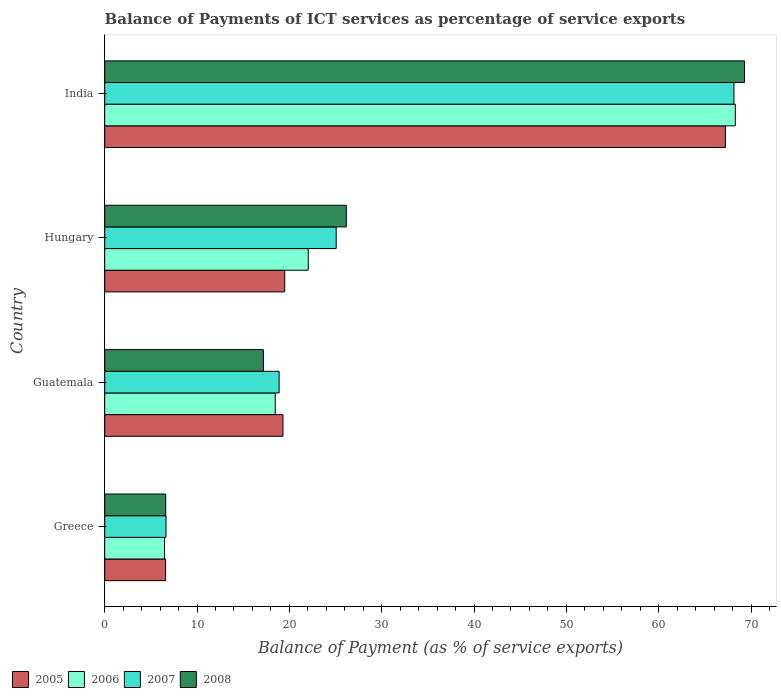Are the number of bars per tick equal to the number of legend labels?
Ensure brevity in your answer.  Yes. How many bars are there on the 4th tick from the bottom?
Give a very brief answer. 4. What is the label of the 2nd group of bars from the top?
Your response must be concise. Hungary. What is the balance of payments of ICT services in 2005 in Hungary?
Give a very brief answer. 19.5. Across all countries, what is the maximum balance of payments of ICT services in 2006?
Provide a short and direct response. 68.29. Across all countries, what is the minimum balance of payments of ICT services in 2008?
Your answer should be compact. 6.6. In which country was the balance of payments of ICT services in 2005 maximum?
Your response must be concise. India. What is the total balance of payments of ICT services in 2006 in the graph?
Ensure brevity in your answer.  115.28. What is the difference between the balance of payments of ICT services in 2008 in Hungary and that in India?
Give a very brief answer. -43.12. What is the difference between the balance of payments of ICT services in 2007 in India and the balance of payments of ICT services in 2008 in Hungary?
Offer a terse response. 41.98. What is the average balance of payments of ICT services in 2006 per country?
Keep it short and to the point. 28.82. What is the difference between the balance of payments of ICT services in 2006 and balance of payments of ICT services in 2008 in Hungary?
Your answer should be compact. -4.13. What is the ratio of the balance of payments of ICT services in 2005 in Greece to that in India?
Give a very brief answer. 0.1. Is the balance of payments of ICT services in 2008 in Hungary less than that in India?
Your answer should be very brief. Yes. Is the difference between the balance of payments of ICT services in 2006 in Greece and India greater than the difference between the balance of payments of ICT services in 2008 in Greece and India?
Offer a terse response. Yes. What is the difference between the highest and the second highest balance of payments of ICT services in 2006?
Provide a short and direct response. 46.25. What is the difference between the highest and the lowest balance of payments of ICT services in 2007?
Offer a terse response. 61.51. In how many countries, is the balance of payments of ICT services in 2007 greater than the average balance of payments of ICT services in 2007 taken over all countries?
Offer a terse response. 1. What does the 4th bar from the bottom in Hungary represents?
Your answer should be compact. 2008. Is it the case that in every country, the sum of the balance of payments of ICT services in 2008 and balance of payments of ICT services in 2005 is greater than the balance of payments of ICT services in 2007?
Your response must be concise. Yes. Are all the bars in the graph horizontal?
Your answer should be very brief. Yes. What is the difference between two consecutive major ticks on the X-axis?
Provide a succinct answer. 10. Are the values on the major ticks of X-axis written in scientific E-notation?
Offer a terse response. No. How are the legend labels stacked?
Your answer should be very brief. Horizontal. What is the title of the graph?
Offer a very short reply. Balance of Payments of ICT services as percentage of service exports. Does "2008" appear as one of the legend labels in the graph?
Your answer should be compact. Yes. What is the label or title of the X-axis?
Your answer should be very brief. Balance of Payment (as % of service exports). What is the Balance of Payment (as % of service exports) of 2005 in Greece?
Provide a short and direct response. 6.59. What is the Balance of Payment (as % of service exports) in 2006 in Greece?
Your answer should be very brief. 6.48. What is the Balance of Payment (as % of service exports) in 2007 in Greece?
Your response must be concise. 6.64. What is the Balance of Payment (as % of service exports) of 2008 in Greece?
Your answer should be very brief. 6.6. What is the Balance of Payment (as % of service exports) in 2005 in Guatemala?
Provide a succinct answer. 19.31. What is the Balance of Payment (as % of service exports) in 2006 in Guatemala?
Offer a terse response. 18.47. What is the Balance of Payment (as % of service exports) of 2007 in Guatemala?
Provide a short and direct response. 18.89. What is the Balance of Payment (as % of service exports) in 2008 in Guatemala?
Keep it short and to the point. 17.18. What is the Balance of Payment (as % of service exports) of 2005 in Hungary?
Your answer should be very brief. 19.5. What is the Balance of Payment (as % of service exports) in 2006 in Hungary?
Provide a short and direct response. 22.04. What is the Balance of Payment (as % of service exports) in 2007 in Hungary?
Your answer should be compact. 25.07. What is the Balance of Payment (as % of service exports) in 2008 in Hungary?
Offer a terse response. 26.17. What is the Balance of Payment (as % of service exports) of 2005 in India?
Your answer should be compact. 67.22. What is the Balance of Payment (as % of service exports) in 2006 in India?
Provide a succinct answer. 68.29. What is the Balance of Payment (as % of service exports) of 2007 in India?
Your answer should be compact. 68.15. What is the Balance of Payment (as % of service exports) in 2008 in India?
Offer a very short reply. 69.29. Across all countries, what is the maximum Balance of Payment (as % of service exports) in 2005?
Your answer should be compact. 67.22. Across all countries, what is the maximum Balance of Payment (as % of service exports) of 2006?
Ensure brevity in your answer.  68.29. Across all countries, what is the maximum Balance of Payment (as % of service exports) in 2007?
Offer a very short reply. 68.15. Across all countries, what is the maximum Balance of Payment (as % of service exports) of 2008?
Provide a short and direct response. 69.29. Across all countries, what is the minimum Balance of Payment (as % of service exports) of 2005?
Provide a short and direct response. 6.59. Across all countries, what is the minimum Balance of Payment (as % of service exports) of 2006?
Provide a short and direct response. 6.48. Across all countries, what is the minimum Balance of Payment (as % of service exports) of 2007?
Provide a short and direct response. 6.64. Across all countries, what is the minimum Balance of Payment (as % of service exports) in 2008?
Your response must be concise. 6.6. What is the total Balance of Payment (as % of service exports) in 2005 in the graph?
Ensure brevity in your answer.  112.61. What is the total Balance of Payment (as % of service exports) of 2006 in the graph?
Give a very brief answer. 115.28. What is the total Balance of Payment (as % of service exports) in 2007 in the graph?
Your answer should be very brief. 118.75. What is the total Balance of Payment (as % of service exports) in 2008 in the graph?
Keep it short and to the point. 119.24. What is the difference between the Balance of Payment (as % of service exports) in 2005 in Greece and that in Guatemala?
Keep it short and to the point. -12.72. What is the difference between the Balance of Payment (as % of service exports) of 2006 in Greece and that in Guatemala?
Your answer should be very brief. -11.99. What is the difference between the Balance of Payment (as % of service exports) of 2007 in Greece and that in Guatemala?
Offer a very short reply. -12.25. What is the difference between the Balance of Payment (as % of service exports) of 2008 in Greece and that in Guatemala?
Ensure brevity in your answer.  -10.58. What is the difference between the Balance of Payment (as % of service exports) in 2005 in Greece and that in Hungary?
Ensure brevity in your answer.  -12.91. What is the difference between the Balance of Payment (as % of service exports) in 2006 in Greece and that in Hungary?
Offer a very short reply. -15.57. What is the difference between the Balance of Payment (as % of service exports) in 2007 in Greece and that in Hungary?
Provide a succinct answer. -18.43. What is the difference between the Balance of Payment (as % of service exports) in 2008 in Greece and that in Hungary?
Your answer should be very brief. -19.56. What is the difference between the Balance of Payment (as % of service exports) in 2005 in Greece and that in India?
Make the answer very short. -60.63. What is the difference between the Balance of Payment (as % of service exports) in 2006 in Greece and that in India?
Offer a terse response. -61.82. What is the difference between the Balance of Payment (as % of service exports) in 2007 in Greece and that in India?
Make the answer very short. -61.51. What is the difference between the Balance of Payment (as % of service exports) of 2008 in Greece and that in India?
Provide a succinct answer. -62.69. What is the difference between the Balance of Payment (as % of service exports) of 2005 in Guatemala and that in Hungary?
Your response must be concise. -0.19. What is the difference between the Balance of Payment (as % of service exports) of 2006 in Guatemala and that in Hungary?
Your answer should be compact. -3.57. What is the difference between the Balance of Payment (as % of service exports) in 2007 in Guatemala and that in Hungary?
Give a very brief answer. -6.18. What is the difference between the Balance of Payment (as % of service exports) of 2008 in Guatemala and that in Hungary?
Provide a succinct answer. -8.98. What is the difference between the Balance of Payment (as % of service exports) of 2005 in Guatemala and that in India?
Ensure brevity in your answer.  -47.91. What is the difference between the Balance of Payment (as % of service exports) in 2006 in Guatemala and that in India?
Ensure brevity in your answer.  -49.83. What is the difference between the Balance of Payment (as % of service exports) of 2007 in Guatemala and that in India?
Provide a succinct answer. -49.26. What is the difference between the Balance of Payment (as % of service exports) of 2008 in Guatemala and that in India?
Provide a short and direct response. -52.11. What is the difference between the Balance of Payment (as % of service exports) of 2005 in Hungary and that in India?
Offer a terse response. -47.72. What is the difference between the Balance of Payment (as % of service exports) of 2006 in Hungary and that in India?
Offer a terse response. -46.25. What is the difference between the Balance of Payment (as % of service exports) in 2007 in Hungary and that in India?
Give a very brief answer. -43.08. What is the difference between the Balance of Payment (as % of service exports) in 2008 in Hungary and that in India?
Ensure brevity in your answer.  -43.12. What is the difference between the Balance of Payment (as % of service exports) of 2005 in Greece and the Balance of Payment (as % of service exports) of 2006 in Guatemala?
Offer a very short reply. -11.88. What is the difference between the Balance of Payment (as % of service exports) of 2005 in Greece and the Balance of Payment (as % of service exports) of 2007 in Guatemala?
Give a very brief answer. -12.3. What is the difference between the Balance of Payment (as % of service exports) of 2005 in Greece and the Balance of Payment (as % of service exports) of 2008 in Guatemala?
Keep it short and to the point. -10.6. What is the difference between the Balance of Payment (as % of service exports) of 2006 in Greece and the Balance of Payment (as % of service exports) of 2007 in Guatemala?
Provide a short and direct response. -12.41. What is the difference between the Balance of Payment (as % of service exports) of 2006 in Greece and the Balance of Payment (as % of service exports) of 2008 in Guatemala?
Your answer should be compact. -10.71. What is the difference between the Balance of Payment (as % of service exports) of 2007 in Greece and the Balance of Payment (as % of service exports) of 2008 in Guatemala?
Provide a short and direct response. -10.54. What is the difference between the Balance of Payment (as % of service exports) in 2005 in Greece and the Balance of Payment (as % of service exports) in 2006 in Hungary?
Offer a very short reply. -15.45. What is the difference between the Balance of Payment (as % of service exports) of 2005 in Greece and the Balance of Payment (as % of service exports) of 2007 in Hungary?
Make the answer very short. -18.48. What is the difference between the Balance of Payment (as % of service exports) in 2005 in Greece and the Balance of Payment (as % of service exports) in 2008 in Hungary?
Provide a short and direct response. -19.58. What is the difference between the Balance of Payment (as % of service exports) in 2006 in Greece and the Balance of Payment (as % of service exports) in 2007 in Hungary?
Provide a succinct answer. -18.59. What is the difference between the Balance of Payment (as % of service exports) in 2006 in Greece and the Balance of Payment (as % of service exports) in 2008 in Hungary?
Your answer should be compact. -19.69. What is the difference between the Balance of Payment (as % of service exports) of 2007 in Greece and the Balance of Payment (as % of service exports) of 2008 in Hungary?
Provide a short and direct response. -19.53. What is the difference between the Balance of Payment (as % of service exports) in 2005 in Greece and the Balance of Payment (as % of service exports) in 2006 in India?
Keep it short and to the point. -61.71. What is the difference between the Balance of Payment (as % of service exports) of 2005 in Greece and the Balance of Payment (as % of service exports) of 2007 in India?
Your answer should be very brief. -61.56. What is the difference between the Balance of Payment (as % of service exports) in 2005 in Greece and the Balance of Payment (as % of service exports) in 2008 in India?
Ensure brevity in your answer.  -62.7. What is the difference between the Balance of Payment (as % of service exports) in 2006 in Greece and the Balance of Payment (as % of service exports) in 2007 in India?
Your response must be concise. -61.67. What is the difference between the Balance of Payment (as % of service exports) of 2006 in Greece and the Balance of Payment (as % of service exports) of 2008 in India?
Ensure brevity in your answer.  -62.81. What is the difference between the Balance of Payment (as % of service exports) of 2007 in Greece and the Balance of Payment (as % of service exports) of 2008 in India?
Give a very brief answer. -62.65. What is the difference between the Balance of Payment (as % of service exports) of 2005 in Guatemala and the Balance of Payment (as % of service exports) of 2006 in Hungary?
Offer a terse response. -2.73. What is the difference between the Balance of Payment (as % of service exports) of 2005 in Guatemala and the Balance of Payment (as % of service exports) of 2007 in Hungary?
Ensure brevity in your answer.  -5.76. What is the difference between the Balance of Payment (as % of service exports) of 2005 in Guatemala and the Balance of Payment (as % of service exports) of 2008 in Hungary?
Your answer should be compact. -6.86. What is the difference between the Balance of Payment (as % of service exports) in 2006 in Guatemala and the Balance of Payment (as % of service exports) in 2007 in Hungary?
Provide a short and direct response. -6.6. What is the difference between the Balance of Payment (as % of service exports) in 2006 in Guatemala and the Balance of Payment (as % of service exports) in 2008 in Hungary?
Keep it short and to the point. -7.7. What is the difference between the Balance of Payment (as % of service exports) of 2007 in Guatemala and the Balance of Payment (as % of service exports) of 2008 in Hungary?
Offer a very short reply. -7.28. What is the difference between the Balance of Payment (as % of service exports) of 2005 in Guatemala and the Balance of Payment (as % of service exports) of 2006 in India?
Give a very brief answer. -48.99. What is the difference between the Balance of Payment (as % of service exports) of 2005 in Guatemala and the Balance of Payment (as % of service exports) of 2007 in India?
Ensure brevity in your answer.  -48.84. What is the difference between the Balance of Payment (as % of service exports) in 2005 in Guatemala and the Balance of Payment (as % of service exports) in 2008 in India?
Your response must be concise. -49.98. What is the difference between the Balance of Payment (as % of service exports) in 2006 in Guatemala and the Balance of Payment (as % of service exports) in 2007 in India?
Offer a very short reply. -49.68. What is the difference between the Balance of Payment (as % of service exports) in 2006 in Guatemala and the Balance of Payment (as % of service exports) in 2008 in India?
Your answer should be very brief. -50.82. What is the difference between the Balance of Payment (as % of service exports) in 2007 in Guatemala and the Balance of Payment (as % of service exports) in 2008 in India?
Offer a very short reply. -50.4. What is the difference between the Balance of Payment (as % of service exports) of 2005 in Hungary and the Balance of Payment (as % of service exports) of 2006 in India?
Provide a short and direct response. -48.8. What is the difference between the Balance of Payment (as % of service exports) in 2005 in Hungary and the Balance of Payment (as % of service exports) in 2007 in India?
Your response must be concise. -48.65. What is the difference between the Balance of Payment (as % of service exports) in 2005 in Hungary and the Balance of Payment (as % of service exports) in 2008 in India?
Provide a short and direct response. -49.79. What is the difference between the Balance of Payment (as % of service exports) of 2006 in Hungary and the Balance of Payment (as % of service exports) of 2007 in India?
Keep it short and to the point. -46.11. What is the difference between the Balance of Payment (as % of service exports) in 2006 in Hungary and the Balance of Payment (as % of service exports) in 2008 in India?
Offer a very short reply. -47.25. What is the difference between the Balance of Payment (as % of service exports) in 2007 in Hungary and the Balance of Payment (as % of service exports) in 2008 in India?
Make the answer very short. -44.22. What is the average Balance of Payment (as % of service exports) of 2005 per country?
Your response must be concise. 28.15. What is the average Balance of Payment (as % of service exports) in 2006 per country?
Your response must be concise. 28.82. What is the average Balance of Payment (as % of service exports) in 2007 per country?
Your response must be concise. 29.69. What is the average Balance of Payment (as % of service exports) in 2008 per country?
Provide a short and direct response. 29.81. What is the difference between the Balance of Payment (as % of service exports) of 2005 and Balance of Payment (as % of service exports) of 2006 in Greece?
Your answer should be very brief. 0.11. What is the difference between the Balance of Payment (as % of service exports) of 2005 and Balance of Payment (as % of service exports) of 2007 in Greece?
Give a very brief answer. -0.05. What is the difference between the Balance of Payment (as % of service exports) of 2005 and Balance of Payment (as % of service exports) of 2008 in Greece?
Keep it short and to the point. -0.02. What is the difference between the Balance of Payment (as % of service exports) in 2006 and Balance of Payment (as % of service exports) in 2007 in Greece?
Offer a very short reply. -0.16. What is the difference between the Balance of Payment (as % of service exports) in 2006 and Balance of Payment (as % of service exports) in 2008 in Greece?
Give a very brief answer. -0.13. What is the difference between the Balance of Payment (as % of service exports) in 2007 and Balance of Payment (as % of service exports) in 2008 in Greece?
Provide a succinct answer. 0.04. What is the difference between the Balance of Payment (as % of service exports) in 2005 and Balance of Payment (as % of service exports) in 2006 in Guatemala?
Offer a terse response. 0.84. What is the difference between the Balance of Payment (as % of service exports) in 2005 and Balance of Payment (as % of service exports) in 2007 in Guatemala?
Keep it short and to the point. 0.42. What is the difference between the Balance of Payment (as % of service exports) of 2005 and Balance of Payment (as % of service exports) of 2008 in Guatemala?
Give a very brief answer. 2.12. What is the difference between the Balance of Payment (as % of service exports) in 2006 and Balance of Payment (as % of service exports) in 2007 in Guatemala?
Offer a very short reply. -0.42. What is the difference between the Balance of Payment (as % of service exports) of 2006 and Balance of Payment (as % of service exports) of 2008 in Guatemala?
Give a very brief answer. 1.28. What is the difference between the Balance of Payment (as % of service exports) of 2007 and Balance of Payment (as % of service exports) of 2008 in Guatemala?
Offer a terse response. 1.71. What is the difference between the Balance of Payment (as % of service exports) in 2005 and Balance of Payment (as % of service exports) in 2006 in Hungary?
Provide a succinct answer. -2.55. What is the difference between the Balance of Payment (as % of service exports) in 2005 and Balance of Payment (as % of service exports) in 2007 in Hungary?
Provide a succinct answer. -5.57. What is the difference between the Balance of Payment (as % of service exports) of 2005 and Balance of Payment (as % of service exports) of 2008 in Hungary?
Offer a very short reply. -6.67. What is the difference between the Balance of Payment (as % of service exports) of 2006 and Balance of Payment (as % of service exports) of 2007 in Hungary?
Your answer should be very brief. -3.03. What is the difference between the Balance of Payment (as % of service exports) of 2006 and Balance of Payment (as % of service exports) of 2008 in Hungary?
Offer a terse response. -4.13. What is the difference between the Balance of Payment (as % of service exports) in 2007 and Balance of Payment (as % of service exports) in 2008 in Hungary?
Make the answer very short. -1.1. What is the difference between the Balance of Payment (as % of service exports) in 2005 and Balance of Payment (as % of service exports) in 2006 in India?
Your response must be concise. -1.08. What is the difference between the Balance of Payment (as % of service exports) of 2005 and Balance of Payment (as % of service exports) of 2007 in India?
Your answer should be very brief. -0.93. What is the difference between the Balance of Payment (as % of service exports) of 2005 and Balance of Payment (as % of service exports) of 2008 in India?
Give a very brief answer. -2.07. What is the difference between the Balance of Payment (as % of service exports) of 2006 and Balance of Payment (as % of service exports) of 2007 in India?
Keep it short and to the point. 0.15. What is the difference between the Balance of Payment (as % of service exports) of 2006 and Balance of Payment (as % of service exports) of 2008 in India?
Ensure brevity in your answer.  -0.99. What is the difference between the Balance of Payment (as % of service exports) of 2007 and Balance of Payment (as % of service exports) of 2008 in India?
Make the answer very short. -1.14. What is the ratio of the Balance of Payment (as % of service exports) of 2005 in Greece to that in Guatemala?
Offer a very short reply. 0.34. What is the ratio of the Balance of Payment (as % of service exports) in 2006 in Greece to that in Guatemala?
Provide a succinct answer. 0.35. What is the ratio of the Balance of Payment (as % of service exports) in 2007 in Greece to that in Guatemala?
Offer a terse response. 0.35. What is the ratio of the Balance of Payment (as % of service exports) in 2008 in Greece to that in Guatemala?
Ensure brevity in your answer.  0.38. What is the ratio of the Balance of Payment (as % of service exports) of 2005 in Greece to that in Hungary?
Your response must be concise. 0.34. What is the ratio of the Balance of Payment (as % of service exports) in 2006 in Greece to that in Hungary?
Ensure brevity in your answer.  0.29. What is the ratio of the Balance of Payment (as % of service exports) in 2007 in Greece to that in Hungary?
Your answer should be compact. 0.26. What is the ratio of the Balance of Payment (as % of service exports) of 2008 in Greece to that in Hungary?
Provide a short and direct response. 0.25. What is the ratio of the Balance of Payment (as % of service exports) in 2005 in Greece to that in India?
Keep it short and to the point. 0.1. What is the ratio of the Balance of Payment (as % of service exports) of 2006 in Greece to that in India?
Offer a terse response. 0.09. What is the ratio of the Balance of Payment (as % of service exports) in 2007 in Greece to that in India?
Your response must be concise. 0.1. What is the ratio of the Balance of Payment (as % of service exports) in 2008 in Greece to that in India?
Your answer should be very brief. 0.1. What is the ratio of the Balance of Payment (as % of service exports) in 2005 in Guatemala to that in Hungary?
Make the answer very short. 0.99. What is the ratio of the Balance of Payment (as % of service exports) in 2006 in Guatemala to that in Hungary?
Give a very brief answer. 0.84. What is the ratio of the Balance of Payment (as % of service exports) in 2007 in Guatemala to that in Hungary?
Your response must be concise. 0.75. What is the ratio of the Balance of Payment (as % of service exports) in 2008 in Guatemala to that in Hungary?
Ensure brevity in your answer.  0.66. What is the ratio of the Balance of Payment (as % of service exports) of 2005 in Guatemala to that in India?
Offer a very short reply. 0.29. What is the ratio of the Balance of Payment (as % of service exports) in 2006 in Guatemala to that in India?
Your answer should be compact. 0.27. What is the ratio of the Balance of Payment (as % of service exports) in 2007 in Guatemala to that in India?
Make the answer very short. 0.28. What is the ratio of the Balance of Payment (as % of service exports) of 2008 in Guatemala to that in India?
Your answer should be compact. 0.25. What is the ratio of the Balance of Payment (as % of service exports) in 2005 in Hungary to that in India?
Ensure brevity in your answer.  0.29. What is the ratio of the Balance of Payment (as % of service exports) in 2006 in Hungary to that in India?
Your response must be concise. 0.32. What is the ratio of the Balance of Payment (as % of service exports) of 2007 in Hungary to that in India?
Keep it short and to the point. 0.37. What is the ratio of the Balance of Payment (as % of service exports) of 2008 in Hungary to that in India?
Your response must be concise. 0.38. What is the difference between the highest and the second highest Balance of Payment (as % of service exports) in 2005?
Offer a terse response. 47.72. What is the difference between the highest and the second highest Balance of Payment (as % of service exports) in 2006?
Your answer should be very brief. 46.25. What is the difference between the highest and the second highest Balance of Payment (as % of service exports) of 2007?
Make the answer very short. 43.08. What is the difference between the highest and the second highest Balance of Payment (as % of service exports) of 2008?
Keep it short and to the point. 43.12. What is the difference between the highest and the lowest Balance of Payment (as % of service exports) of 2005?
Offer a very short reply. 60.63. What is the difference between the highest and the lowest Balance of Payment (as % of service exports) in 2006?
Your answer should be very brief. 61.82. What is the difference between the highest and the lowest Balance of Payment (as % of service exports) of 2007?
Make the answer very short. 61.51. What is the difference between the highest and the lowest Balance of Payment (as % of service exports) in 2008?
Make the answer very short. 62.69. 